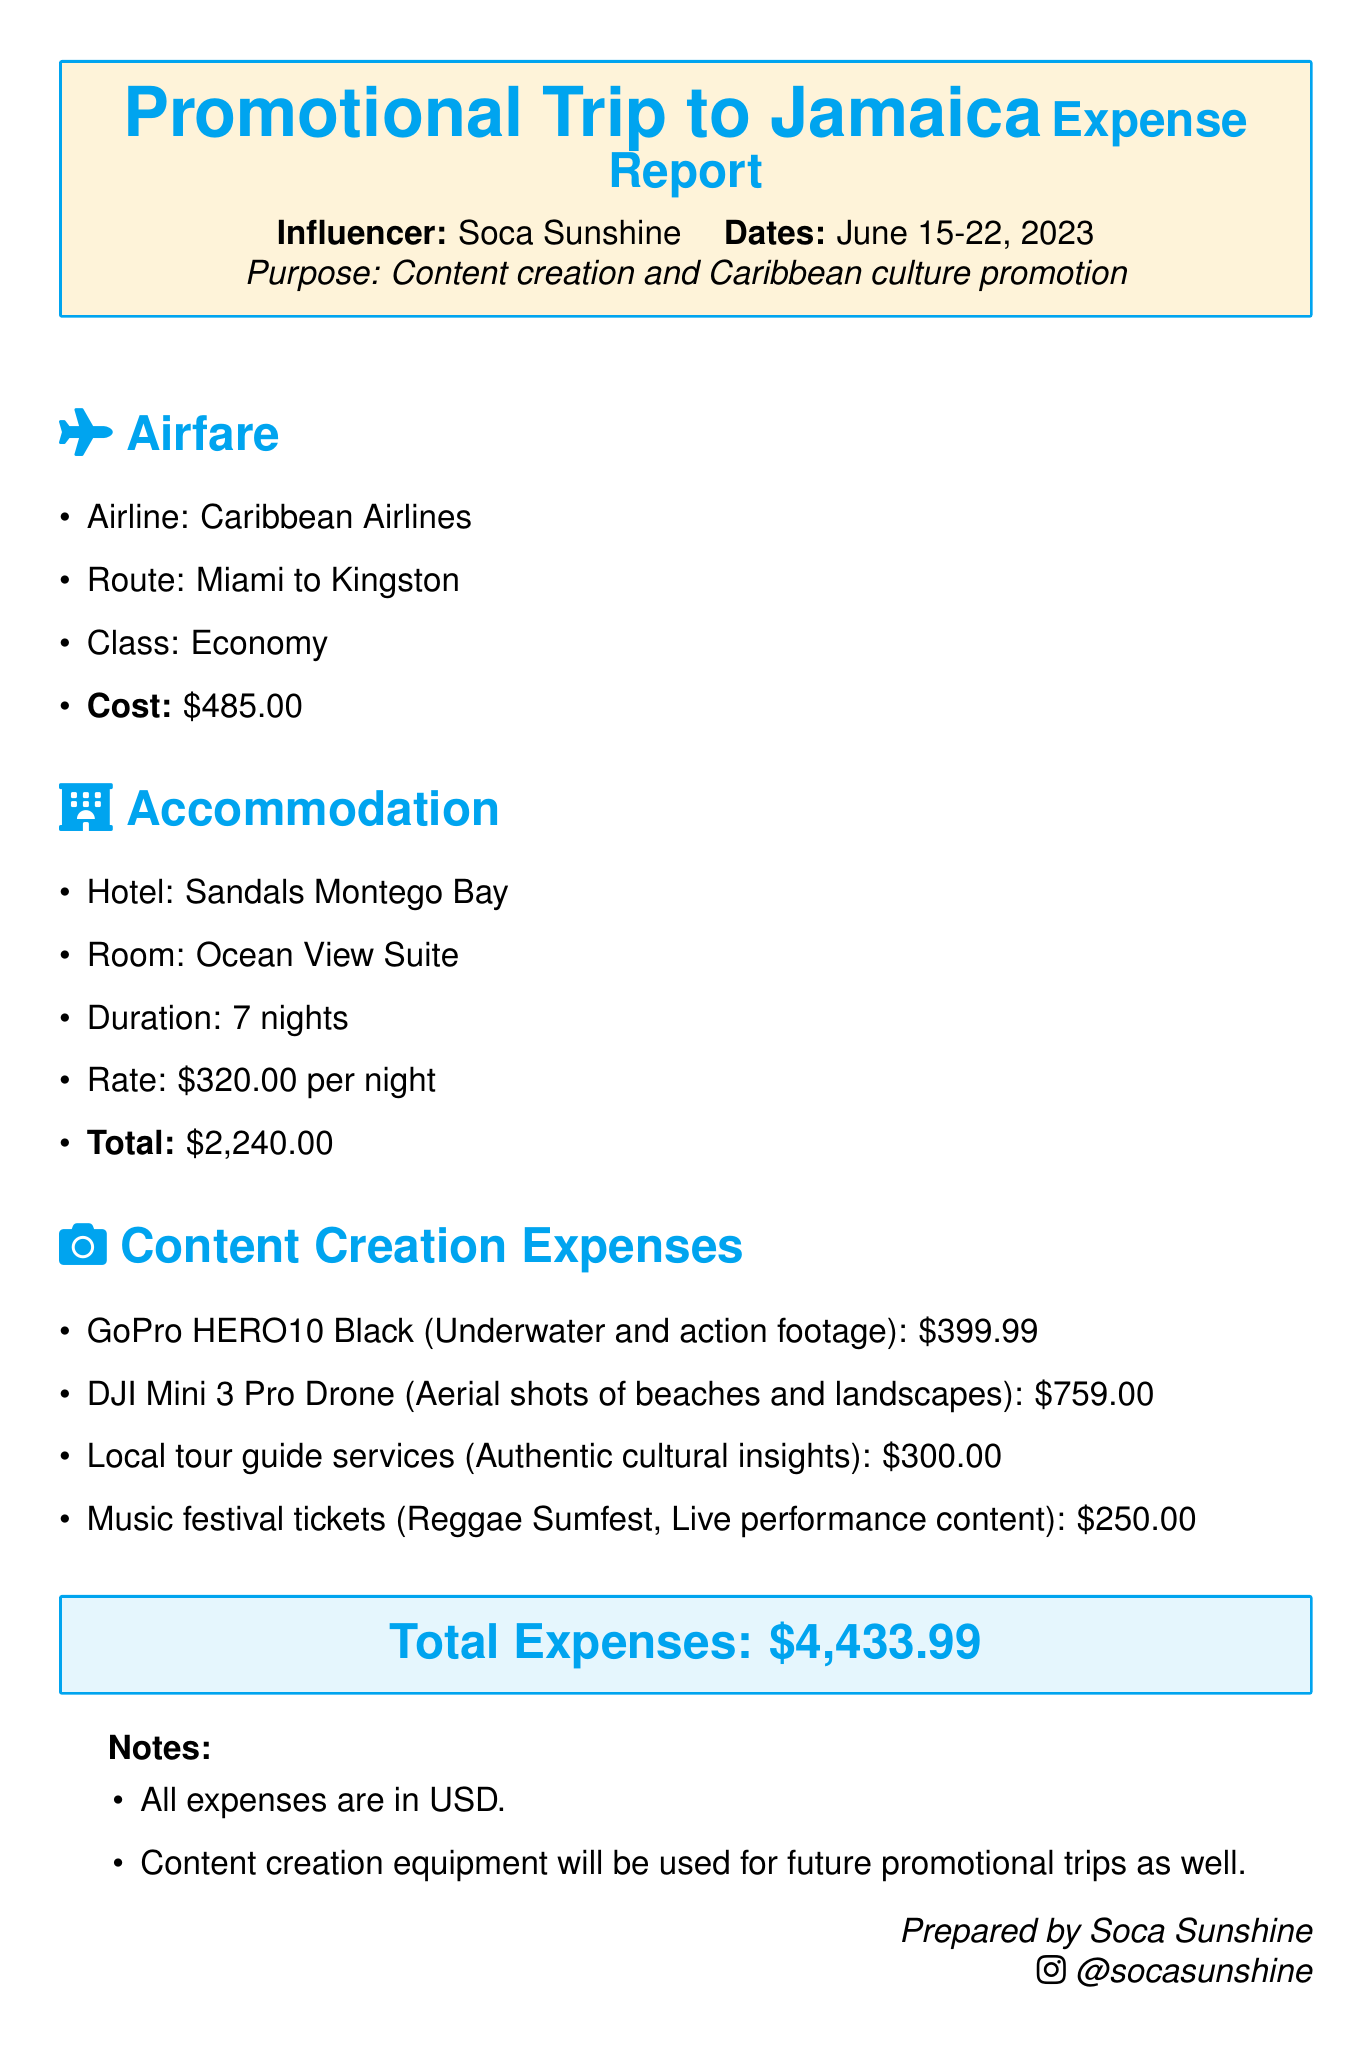What is the total cost of airfare? The airfare cost is listed in the document as $485.00.
Answer: $485.00 What is the hotel name? The document mentions the hotel as Sandals Montego Bay.
Answer: Sandals Montego Bay How many nights did the influencer stay at the hotel? The duration of the stay is specified as 7 nights.
Answer: 7 nights What is the cost of the GoPro HERO10 Black? The document specifies the GoPro HERO10 Black cost as $399.99.
Answer: $399.99 What is the total expense reported in the document? The total expenses are summed up at the end as $4,433.99.
Answer: $4,433.99 What type of content creation expenses were incurred? The document lists various equipment and services related to content creation.
Answer: Equipment and services How much did the music festival tickets cost? The cost for the music festival ticket is mentioned as $250.00.
Answer: $250.00 What is the room type at the hotel? The document specifies the room type as Ocean View Suite.
Answer: Ocean View Suite What is the reason for the trip? The purpose of the trip is stated as content creation and Caribbean culture promotion.
Answer: Content creation and Caribbean culture promotion 